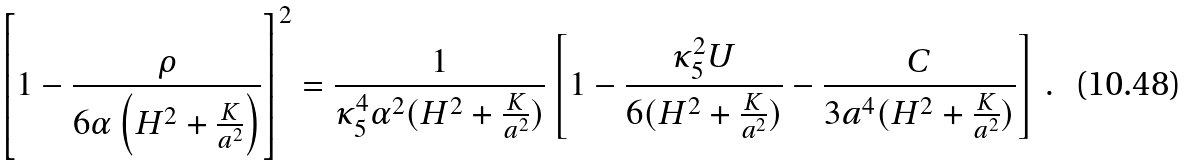Convert formula to latex. <formula><loc_0><loc_0><loc_500><loc_500>\left [ 1 - \frac { \rho } { 6 \alpha \left ( H ^ { 2 } + \frac { K } { a ^ { 2 } } \right ) } \right ] ^ { 2 } = \frac { 1 } { \kappa _ { 5 } ^ { 4 } \alpha ^ { 2 } ( H ^ { 2 } + \frac { K } { a ^ { 2 } } ) } \left [ 1 - \frac { \kappa _ { 5 } ^ { 2 } U } { 6 ( H ^ { 2 } + \frac { K } { a ^ { 2 } } ) } - \frac { C } { 3 a ^ { 4 } ( H ^ { 2 } + \frac { K } { a ^ { 2 } } ) } \right ] \, .</formula> 